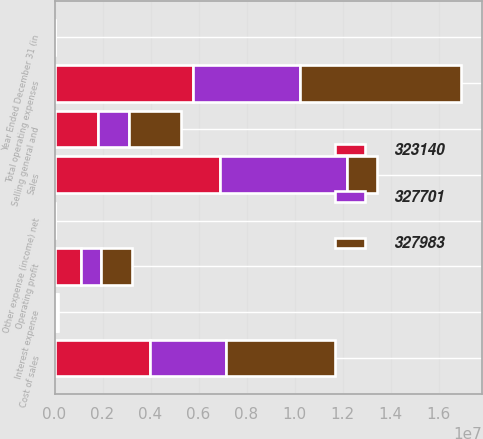<chart> <loc_0><loc_0><loc_500><loc_500><stacked_bar_chart><ecel><fcel>Year Ended December 31 (in<fcel>Sales<fcel>Cost of sales<fcel>Selling general and<fcel>Other expense (income) net<fcel>Total operating expenses<fcel>Operating profit<fcel>Interest expense<nl><fcel>327983<fcel>2005<fcel>1.26467e+06<fcel>4.53969e+06<fcel>2.17575e+06<fcel>4596<fcel>6.72004e+06<fcel>1.26467e+06<fcel>44933<nl><fcel>323140<fcel>2004<fcel>6.8893e+06<fcel>3.99664e+06<fcel>1.79567e+06<fcel>8141<fcel>5.78417e+06<fcel>1.10513e+06<fcel>54984<nl><fcel>327701<fcel>2003<fcel>5.29388e+06<fcel>3.15481e+06<fcel>1.31636e+06<fcel>785<fcel>4.44788e+06<fcel>845995<fcel>59049<nl></chart> 